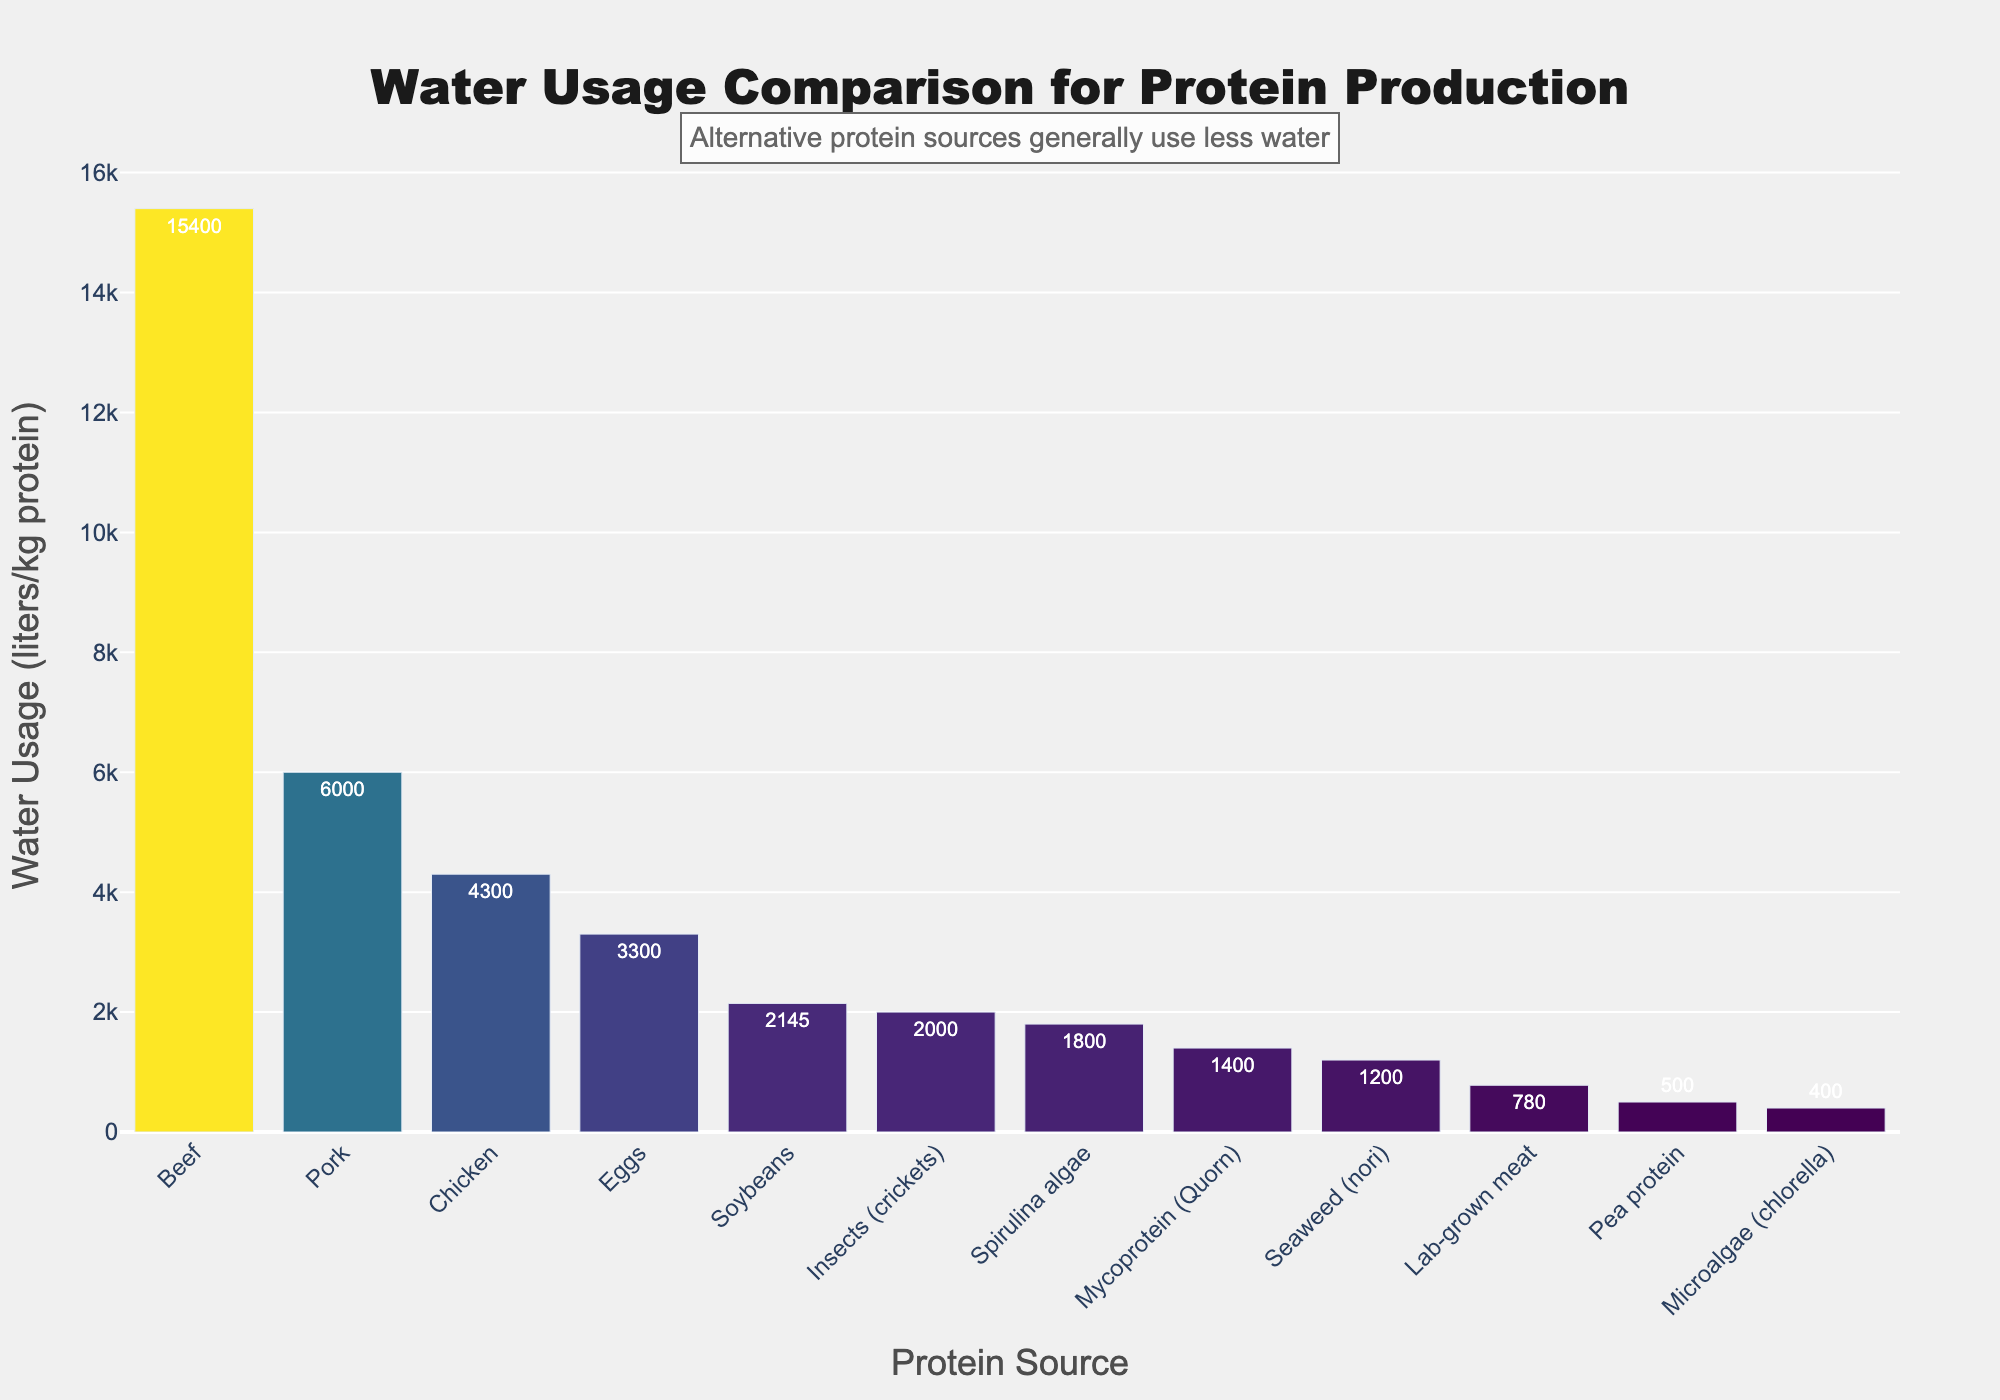What alternative protein source has the lowest water usage per kilogram of protein? The bar chart visualizes the water usage for each protein source. By inspecting the shortest bar among the alternative proteins, one can identify the source with the lowest water usage.
Answer: Microalgae (chlorella) How much more water does it take to produce 1kg of beef protein compared to 1kg of chicken protein? Locate the bars for beef and chicken. Subtract the water usage value for chicken from the water usage value for beef (15,400 liters for beef - 4,300 liters for chicken = 11,100 liters).
Answer: 11,100 liters What is the average water usage per kilogram of protein for insects (crickets), spirulina algae, and mycoprotein (Quorn)? Find the respective water usage values for the three sources (2,000 for insects, 1,800 for spirulina, and 1,400 for mycoprotein). Sum these values (2,000 + 1,800 + 1,400 = 5,200) and divide by the number of sources (5,200 / 3).
Answer: 1,733.33 liters Which protein source has the highest water usage, and what is its value? Identify the tallest bar in the chart and the corresponding label to find the highest water usage source.
Answer: Beef, 15,400 liters Does soybeans or lab-grown meat use less water per kilogram of protein? Compare the height of the bars for soybeans and lab-grown meat. Notice that the lab-grown meat bar is shorter.
Answer: Lab-grown meat What is the total water usage for producing 1kg of protein from seaweed (nori) and lab-grown meat? Find the water usage values for seaweed and lab-grown meat (1,200 liters and 780 liters respectively). Then, sum these values (1,200 + 780 = 1,980 liters).
Answer: 1,980 liters Which traditional protein source uses the least water, and what is its value? Review the bars for traditional protein sources (beef, pork, chicken, and eggs) and find the shortest one.
Answer: Eggs, 3,300 liters What is the difference in water usage for producing 1kg of protein from pork compared to pea protein? Locate the bars for pork and pea protein. Subtract the water usage value for pea protein from the value for pork (6,000 liters for pork - 500 liters for pea protein = 5,500 liters).
Answer: 5,500 liters What is the average water usage per kilogram of protein for the four traditional protein sources listed? Sum the water usage values for beef, pork, chicken, and eggs (15,400 + 6,000 + 4,300 + 3,300 = 29,000) and divide by the number of sources (29,000 / 4).
Answer: 7,250 liters Which protein sources fall into the upper half of water usage values? Identify the protein sources with water usage values above the median of the dataset. Sort the water usage values and find the median. The values above the median include those for beef, pork, and chicken.
Answer: Beef, Pork, Chicken 